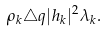Convert formula to latex. <formula><loc_0><loc_0><loc_500><loc_500>\rho _ { k } \triangle q | h _ { k } | ^ { 2 } \lambda _ { k } .</formula> 